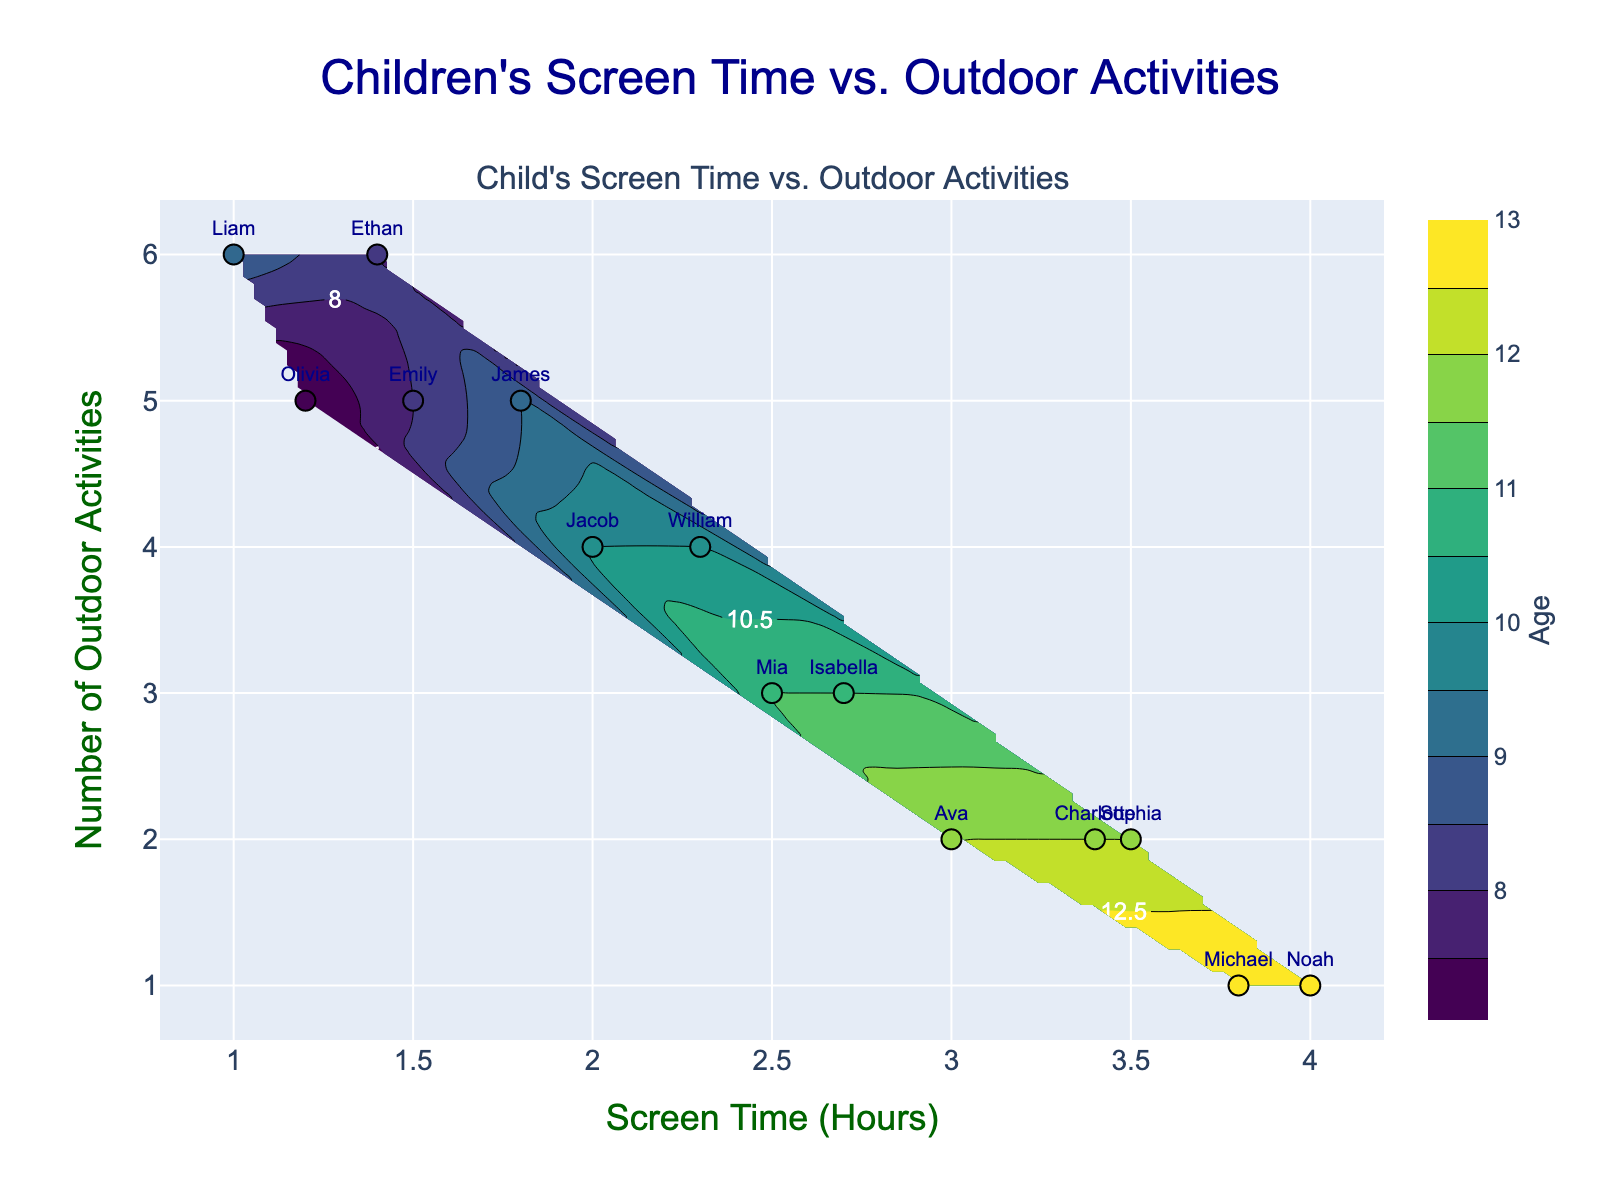What is the title of the figure? The title is always at the top of the figure and it provides a general description of what the figure represents. Here, the title is "Children's Screen Time vs. Outdoor Activities."
Answer: Children's Screen Time vs. Outdoor Activities How many hours of screen time does Emily have? To find this, look for the marker labeled "Emily" on the scatter plot and note its corresponding x-axis value. The x-axis represents screen time in hours.
Answer: 1.5 Which child has the highest number of outdoor activities? The y-axis represents the number of outdoor activities. To answer this, look for the highest y-value on the scatter plot and identify the corresponding child's name.
Answer: Liam and Ethan What is the color associated with the age of children in the contour plot? The color in a contour plot represents different levels of a third variable, in this case, age. The color scale bar next to the plot indicates this relationship with age. Colors range from light to dark shades.
Answer: Viridis color scale Comparing Liam and Jacob, who has more screen time? First, identify the markers for Liam and Jacob. Then compare their x-axis positions which represent screen time hours. Liam's x-value is 1.0 and Jacob's is 2.0.
Answer: Jacob What is the average number of outdoor activities for children with more than 3 hours of screen time? Identify the children with screen time more than 3 hours (Sophia, Noah, Ava, Charlotte, and Michael). Then, sum their number of outdoor activities and divide by the count: (2+1+2+2+1)/5 = 1.6
Answer: 1.6 What is the contour pattern like in the figure? Observe the contour lines which represent age variances across screen time and outdoor activities. Descriptions include smooth variations, clustering, and gradient. Look for smooth transitions or abrupt changes.
Answer: Smooth gradients with noticeable transitions How does screen time relate to the number of outdoor activities in the plot? Look for trends among the datapoints and color gradients. Generally, notice if there's an overall pattern indicating an inverse relationship (more screen time, fewer activities, and vice-versa).
Answer: Inversely related Which age group tends to have higher screen time and fewer outdoor activities? Look at the colors corresponding to higher screen time (towards the right on x-axis) and fewer outdoor activities (towards the bottom y-axis). Higher ages tend to occupy this region.
Answer: Older children (around 12-13 years) What is the median screen time for all the children in the plot? List all screen time values: 1.0, 1.2, 1.4, 1.5, 1.8, 2.0, 2.3, 2.5, 2.7, 3.0, 3.4, 3.5, 3.8, and 4.0, then find the middle value which is 2.4 (average of the middle two values 2.3 and 2.5 as there are 14 values).
Answer: 2.4 